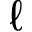Convert formula to latex. <formula><loc_0><loc_0><loc_500><loc_500>\ell</formula> 